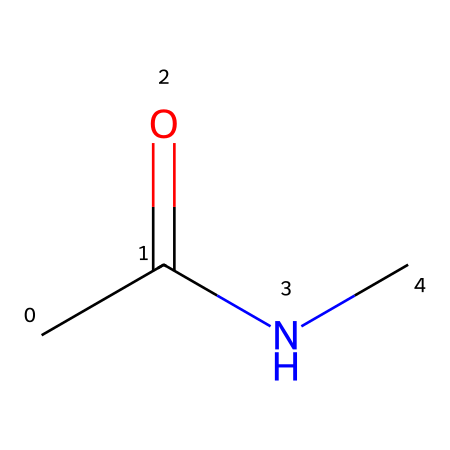What is the functional group present in this chemical? The chemical structure contains an amine (NC) and a carbonyl (C=O from CC(=O)). The presence of the nitrogen and the carbonyl group indicates the functional group as an amide.
Answer: amide How many carbon atoms are in the chemical? Looking at the SMILES representation, "CC(=O)NC" shows two carbon atoms (CC), which indicates that there are two carbon atoms in total.
Answer: 2 What type of solid phase is this compound likely to belong to? Since this compound has functional groups typical of small organic molecules, it is expected to have properties similar to an organic solid. As it is a less complex structure, it serves as part of a sound-absorbing material.
Answer: organic solid What is the total number of hydrogen atoms in the chemical? In the given SMILES, when we break down CC(=O)NC, the carbon atoms are bonded to enough hydrogens to have their typical valency satisfied; thus, the overall count shows a total of five hydrogen atoms.
Answer: 5 What role does the nitrogen atom play in this chemical? The nitrogen atom, part of the amide group, contributes to the chemical’s properties, whereas it indicates potential for hydrogen bonding, which can enhance sound-absorbing characteristics in foams used in studios.
Answer: hydrogen bonding What type of bond connects the carbon to the nitrogen in this molecule? In the SMILES, the bond between carbon (from the amide functional group) and nitrogen is a single bond (C-N), indicating a direct connection that influences the molecule's stability and properties.
Answer: single bond 